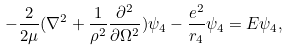Convert formula to latex. <formula><loc_0><loc_0><loc_500><loc_500>- \frac { 2 } { 2 \mu } ( \nabla ^ { 2 } + \frac { 1 } { \rho ^ { 2 } } \frac { \partial ^ { 2 } } { \partial \Omega ^ { 2 } } ) \psi _ { 4 } - \frac { e ^ { 2 } } { r _ { 4 } } \psi _ { 4 } = E \psi _ { 4 } ,</formula> 